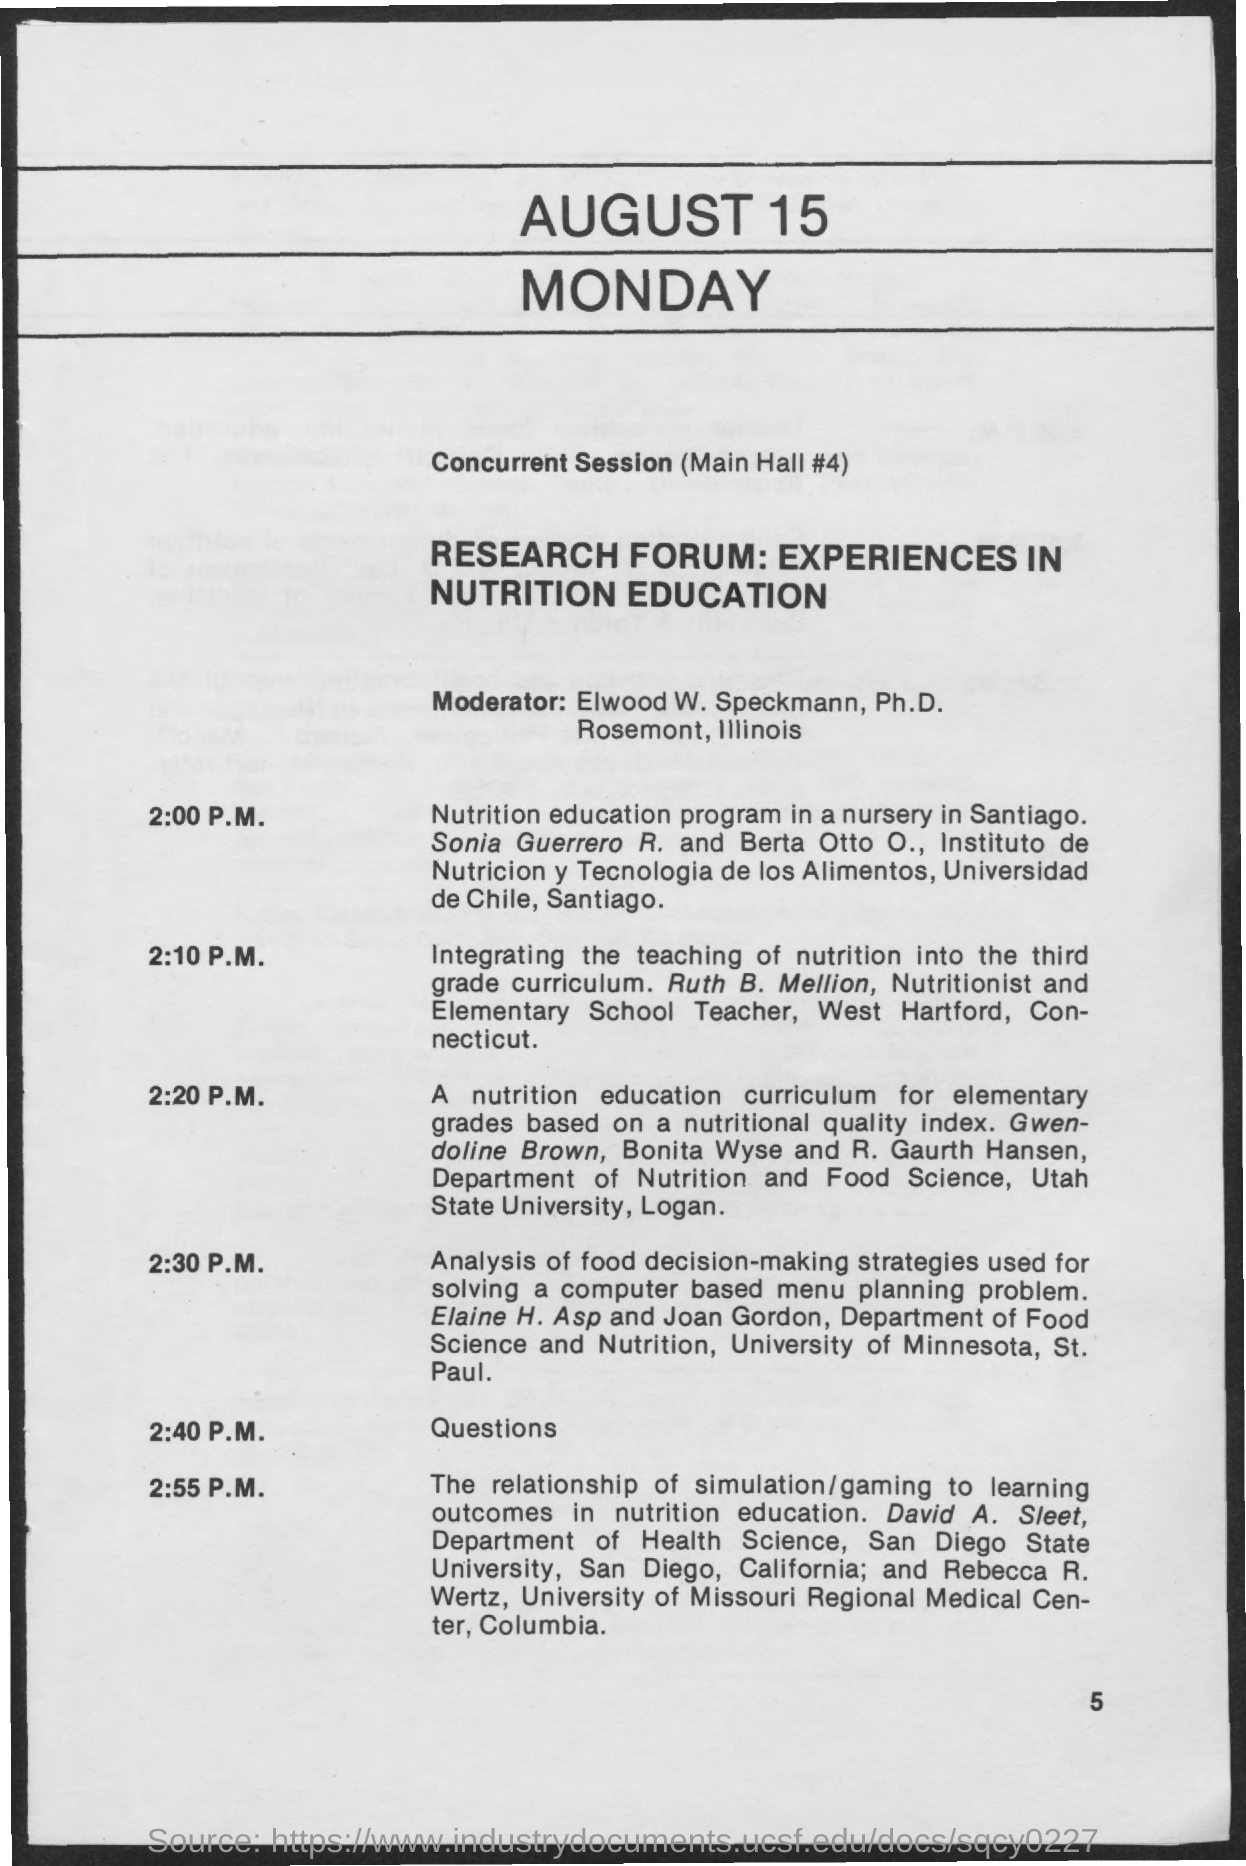What is the page no mentioned in this document?
Ensure brevity in your answer.  5. Who is the Moderator for the sessions?
Give a very brief answer. Elwood W. Speckmann, Ph.D. What time is the questions session scheduled?
Keep it short and to the point. 2:40 P.M. Which Paper is presented by Ruth B. Mellion in the research forum?
Your response must be concise. Integrating the Teaching of nutrition into the third Grade curriculum. 